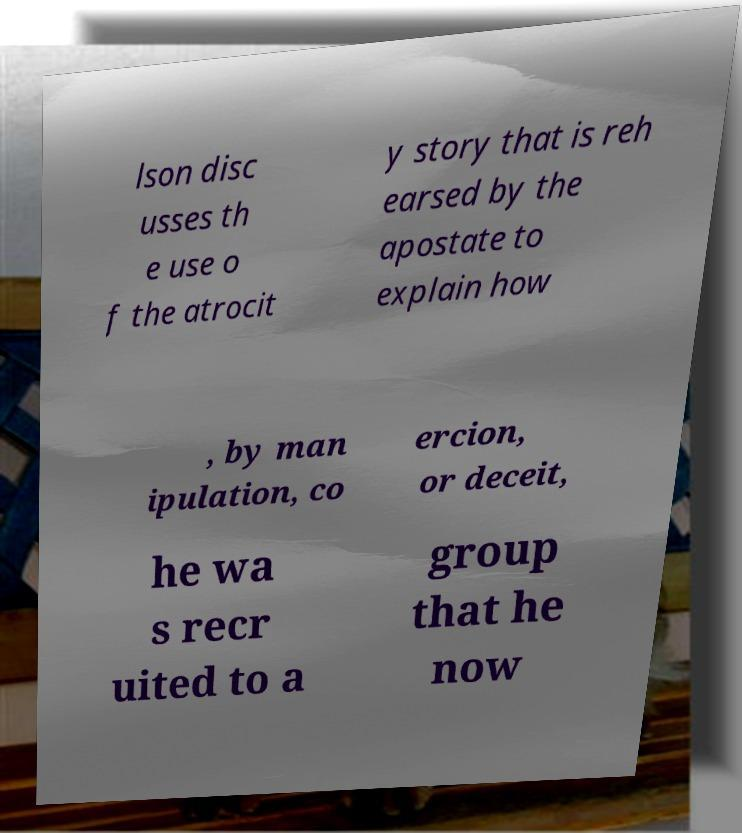Could you extract and type out the text from this image? lson disc usses th e use o f the atrocit y story that is reh earsed by the apostate to explain how , by man ipulation, co ercion, or deceit, he wa s recr uited to a group that he now 